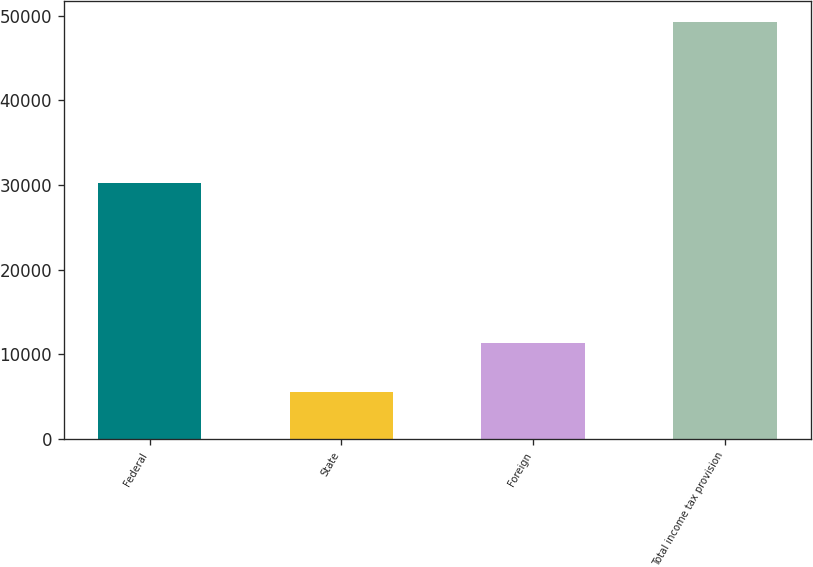<chart> <loc_0><loc_0><loc_500><loc_500><bar_chart><fcel>Federal<fcel>State<fcel>Foreign<fcel>Total income tax provision<nl><fcel>30224<fcel>5511<fcel>11389<fcel>49268<nl></chart> 